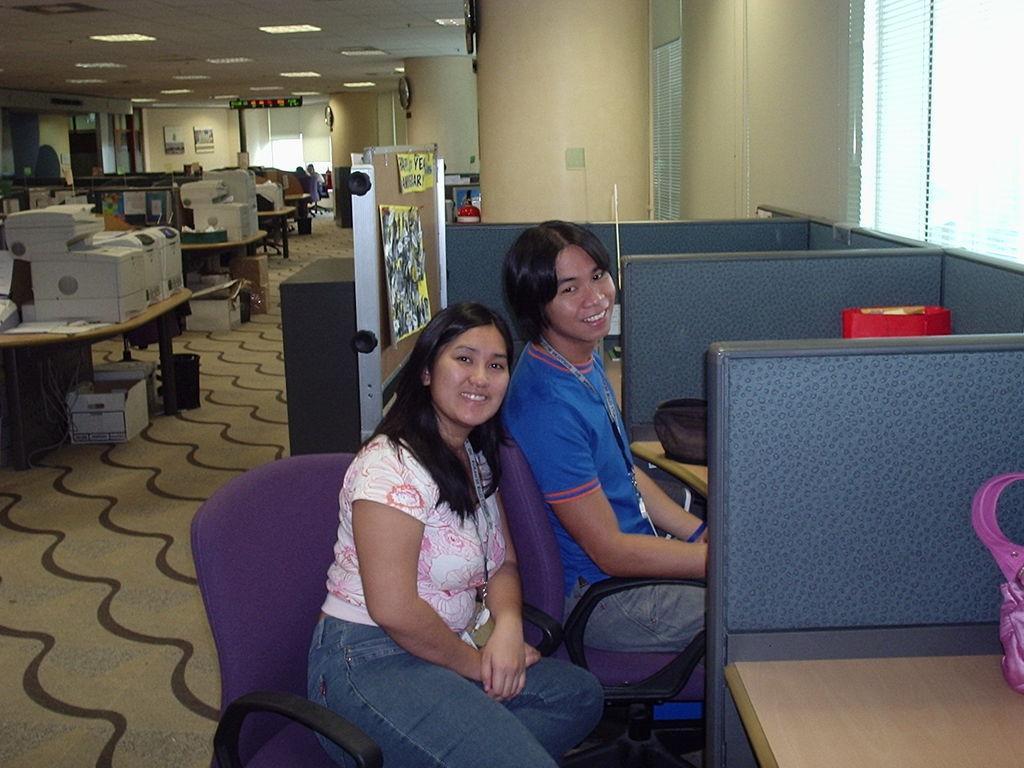Describe this image in one or two sentences. This 2 persons are sitting on a chair. In-front of this 2 persons there is a table, on this table there is a bag. We can able to see number of tables and electronic devices. Under the table there is a cardboard box. Posters on this board. Clock on pillar. 